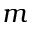<formula> <loc_0><loc_0><loc_500><loc_500>m</formula> 